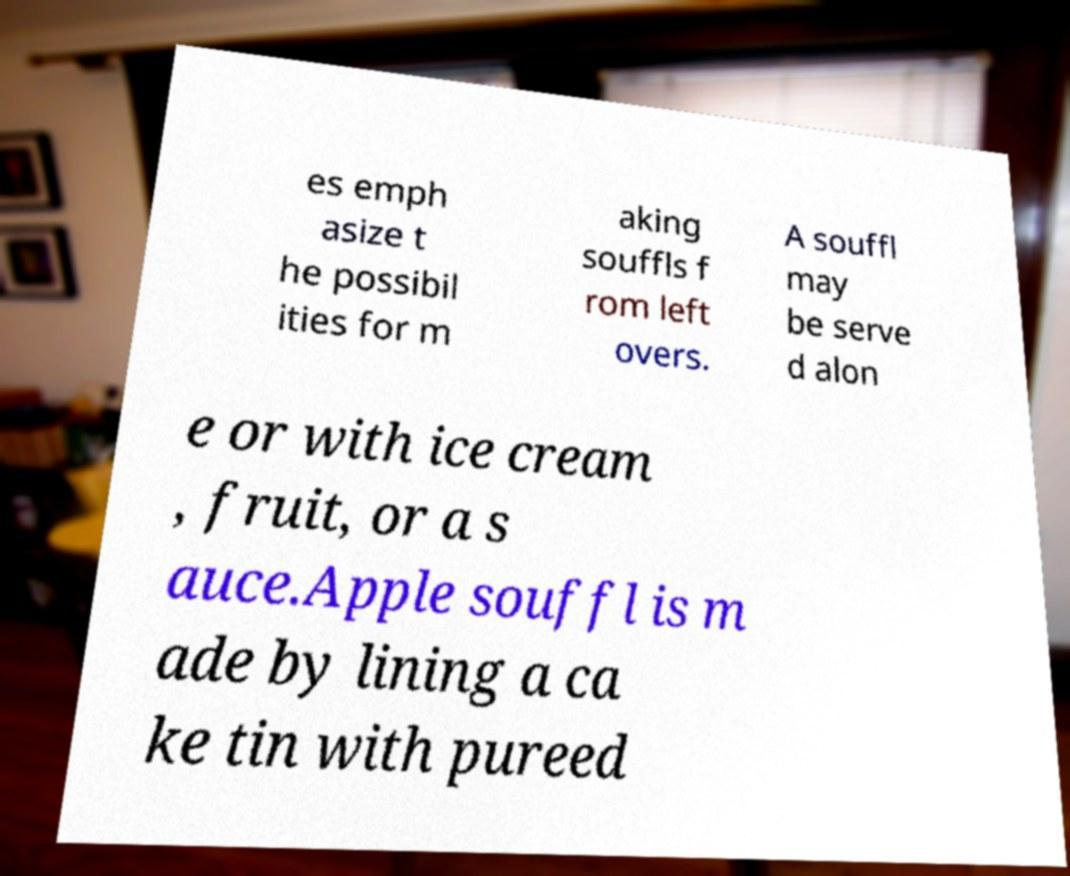There's text embedded in this image that I need extracted. Can you transcribe it verbatim? es emph asize t he possibil ities for m aking souffls f rom left overs. A souffl may be serve d alon e or with ice cream , fruit, or a s auce.Apple souffl is m ade by lining a ca ke tin with pureed 